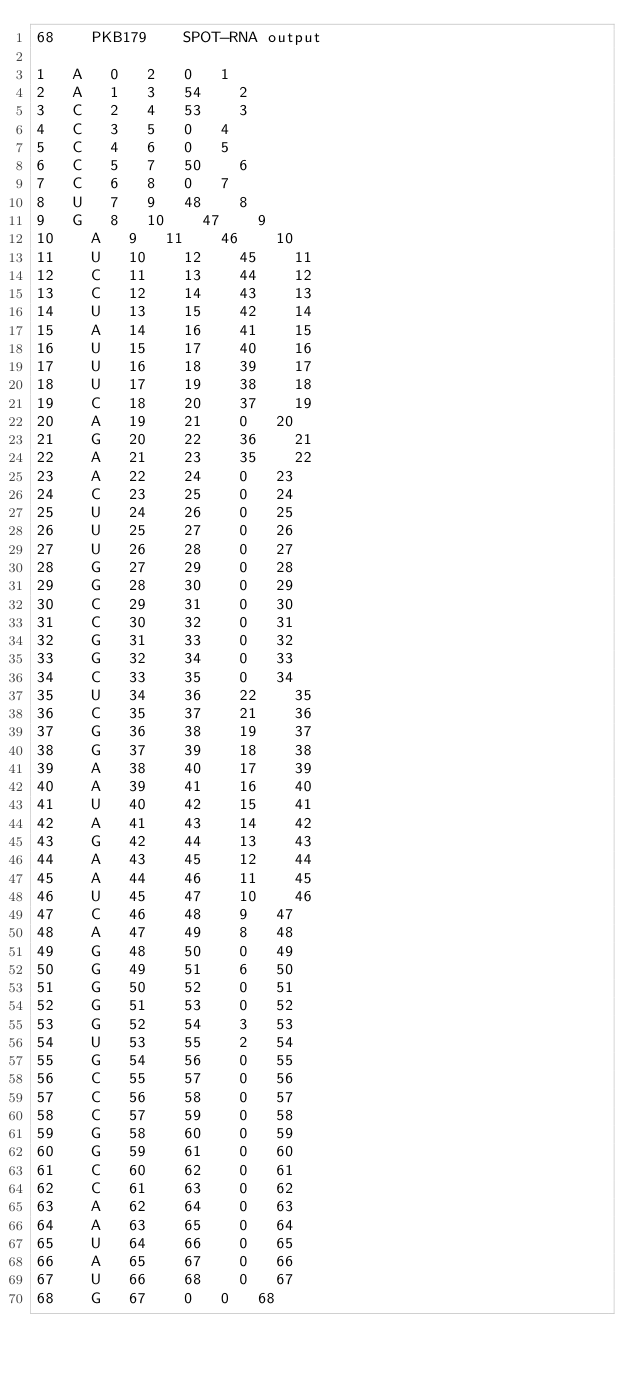Convert code to text. <code><loc_0><loc_0><loc_500><loc_500><_XML_>68		PKB179		SPOT-RNA output

1		A		0		2		0		1
2		A		1		3		54		2
3		C		2		4		53		3
4		C		3		5		0		4
5		C		4		6		0		5
6		C		5		7		50		6
7		C		6		8		0		7
8		U		7		9		48		8
9		G		8		10		47		9
10		A		9		11		46		10
11		U		10		12		45		11
12		C		11		13		44		12
13		C		12		14		43		13
14		U		13		15		42		14
15		A		14		16		41		15
16		U		15		17		40		16
17		U		16		18		39		17
18		U		17		19		38		18
19		C		18		20		37		19
20		A		19		21		0		20
21		G		20		22		36		21
22		A		21		23		35		22
23		A		22		24		0		23
24		C		23		25		0		24
25		U		24		26		0		25
26		U		25		27		0		26
27		U		26		28		0		27
28		G		27		29		0		28
29		G		28		30		0		29
30		C		29		31		0		30
31		C		30		32		0		31
32		G		31		33		0		32
33		G		32		34		0		33
34		C		33		35		0		34
35		U		34		36		22		35
36		C		35		37		21		36
37		G		36		38		19		37
38		G		37		39		18		38
39		A		38		40		17		39
40		A		39		41		16		40
41		U		40		42		15		41
42		A		41		43		14		42
43		G		42		44		13		43
44		A		43		45		12		44
45		A		44		46		11		45
46		U		45		47		10		46
47		C		46		48		9		47
48		A		47		49		8		48
49		G		48		50		0		49
50		G		49		51		6		50
51		G		50		52		0		51
52		G		51		53		0		52
53		G		52		54		3		53
54		U		53		55		2		54
55		G		54		56		0		55
56		C		55		57		0		56
57		C		56		58		0		57
58		C		57		59		0		58
59		G		58		60		0		59
60		G		59		61		0		60
61		C		60		62		0		61
62		C		61		63		0		62
63		A		62		64		0		63
64		A		63		65		0		64
65		U		64		66		0		65
66		A		65		67		0		66
67		U		66		68		0		67
68		G		67		0		0		68
</code> 